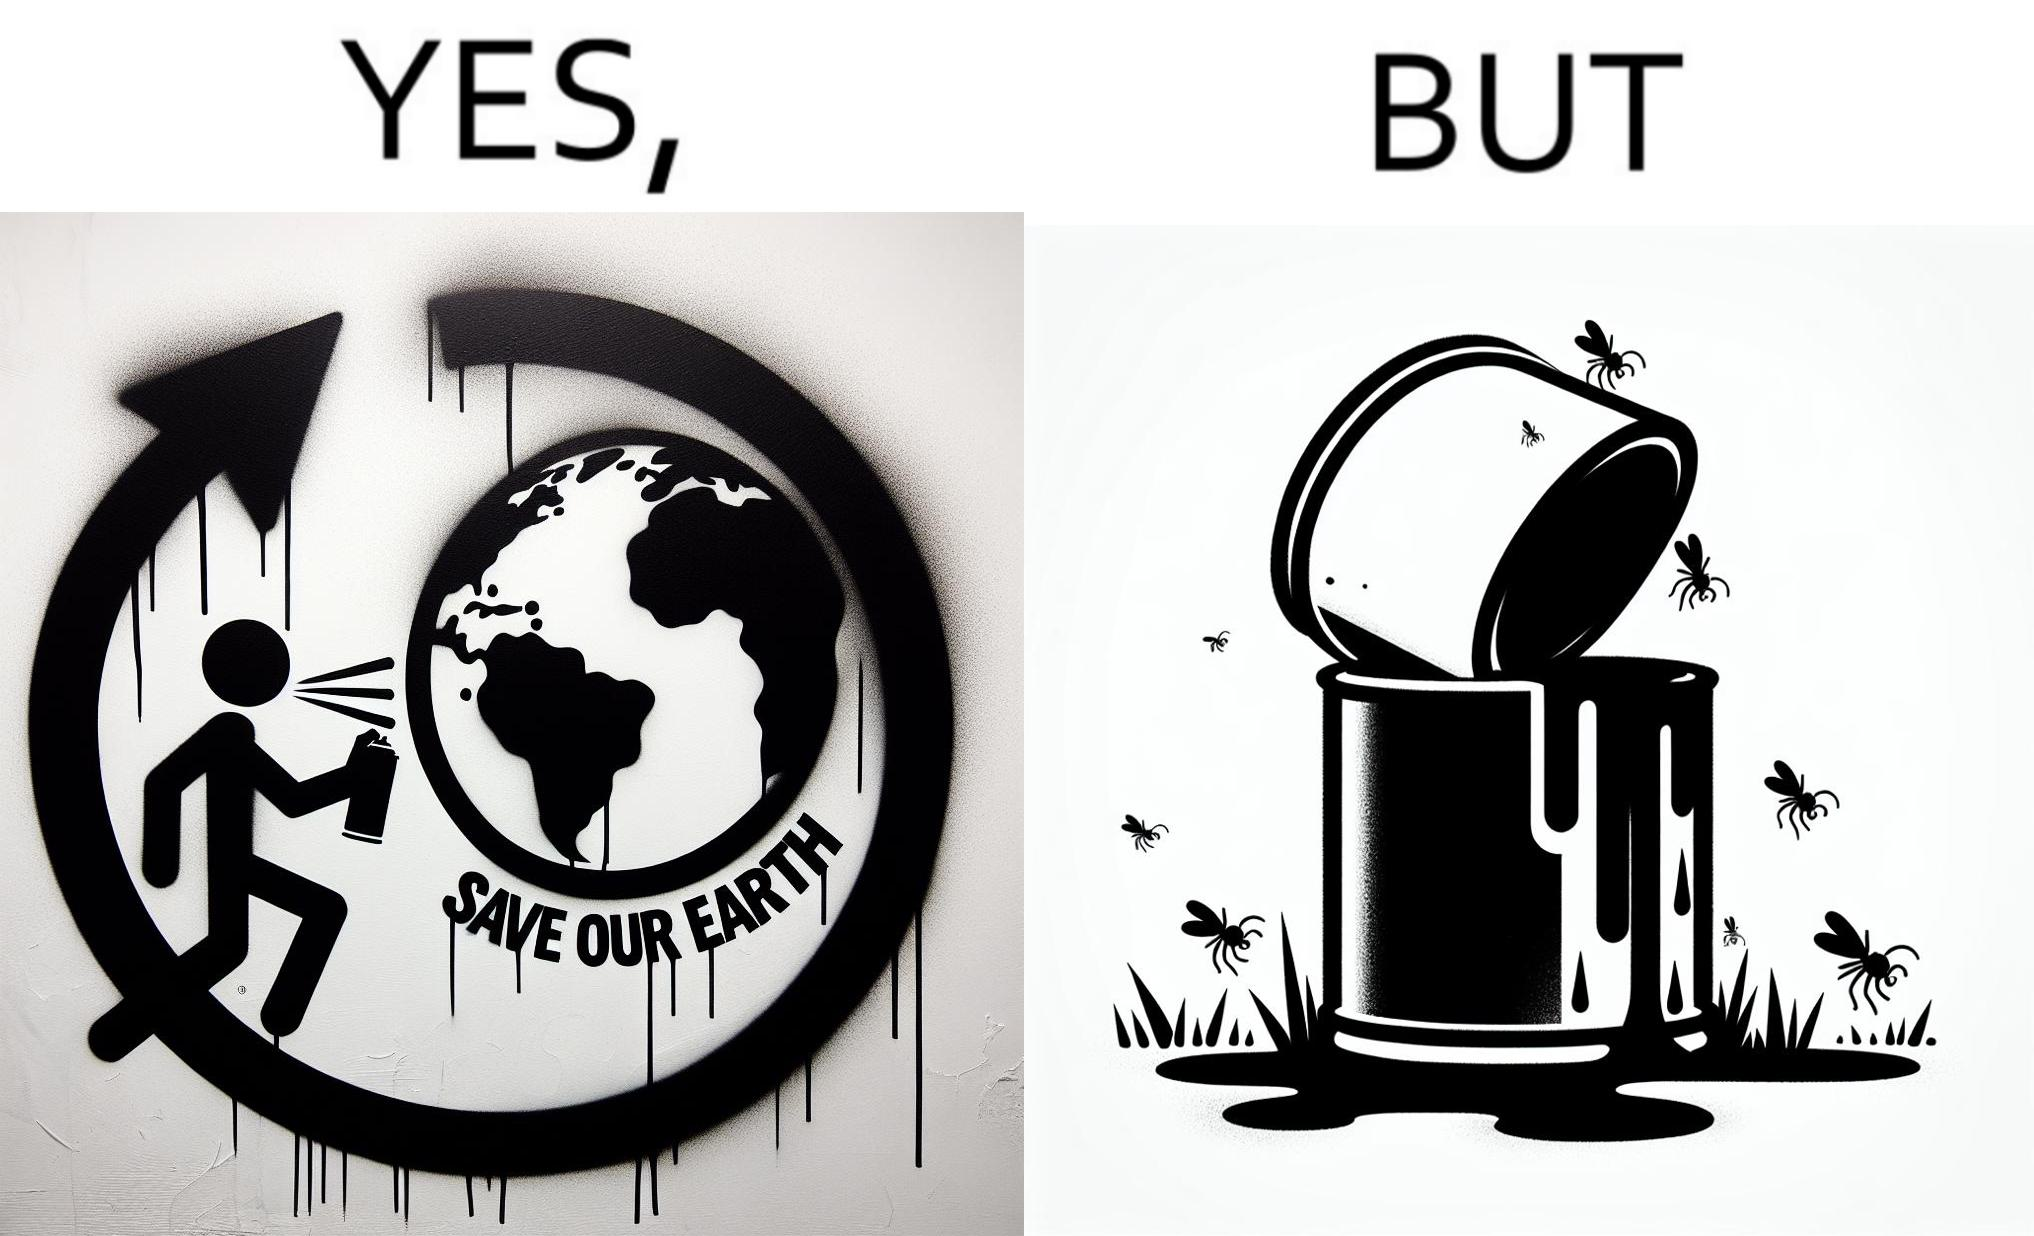Why is this image considered satirical? The image is ironical, as the cans of paint used to make graffiti on the theme "Save the Earth" seems to be destroying the Earth when it overflows on the grass, as it is harmful for the flora and fauna, as can be seen from the dying insects. 